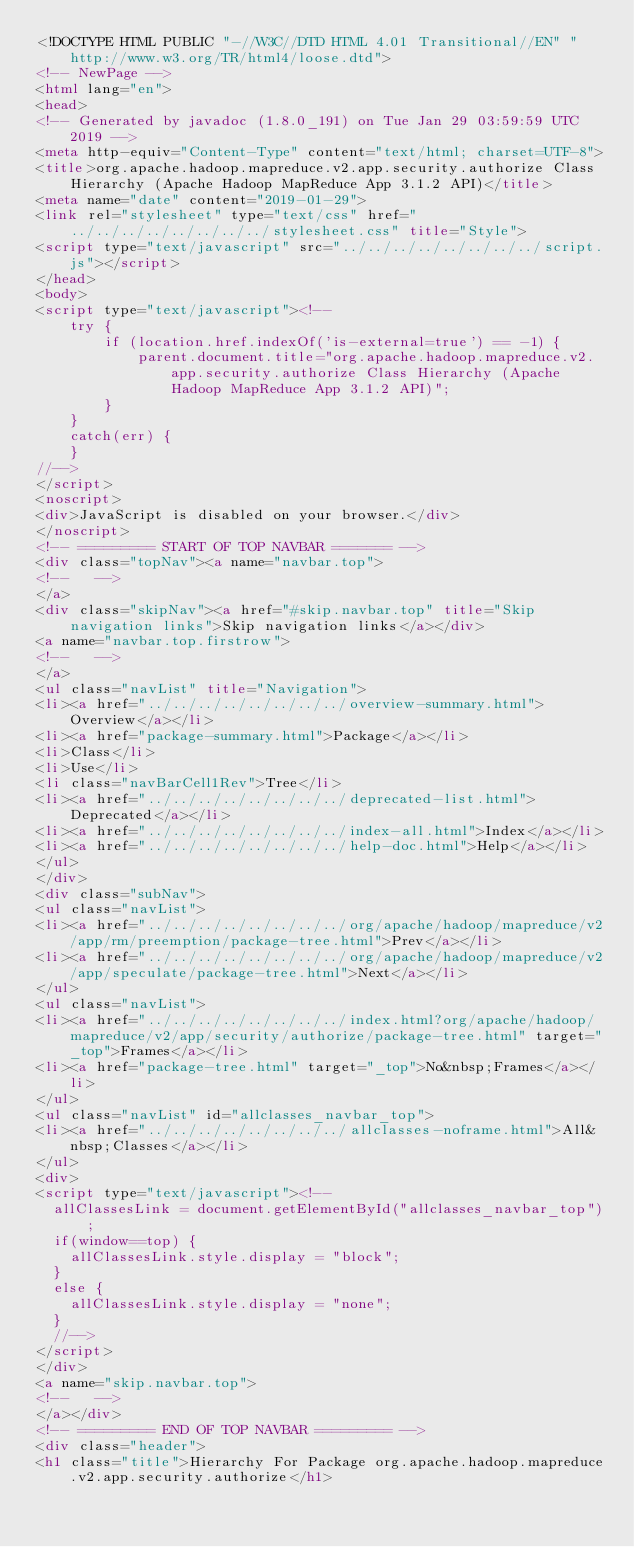Convert code to text. <code><loc_0><loc_0><loc_500><loc_500><_HTML_><!DOCTYPE HTML PUBLIC "-//W3C//DTD HTML 4.01 Transitional//EN" "http://www.w3.org/TR/html4/loose.dtd">
<!-- NewPage -->
<html lang="en">
<head>
<!-- Generated by javadoc (1.8.0_191) on Tue Jan 29 03:59:59 UTC 2019 -->
<meta http-equiv="Content-Type" content="text/html; charset=UTF-8">
<title>org.apache.hadoop.mapreduce.v2.app.security.authorize Class Hierarchy (Apache Hadoop MapReduce App 3.1.2 API)</title>
<meta name="date" content="2019-01-29">
<link rel="stylesheet" type="text/css" href="../../../../../../../../stylesheet.css" title="Style">
<script type="text/javascript" src="../../../../../../../../script.js"></script>
</head>
<body>
<script type="text/javascript"><!--
    try {
        if (location.href.indexOf('is-external=true') == -1) {
            parent.document.title="org.apache.hadoop.mapreduce.v2.app.security.authorize Class Hierarchy (Apache Hadoop MapReduce App 3.1.2 API)";
        }
    }
    catch(err) {
    }
//-->
</script>
<noscript>
<div>JavaScript is disabled on your browser.</div>
</noscript>
<!-- ========= START OF TOP NAVBAR ======= -->
<div class="topNav"><a name="navbar.top">
<!--   -->
</a>
<div class="skipNav"><a href="#skip.navbar.top" title="Skip navigation links">Skip navigation links</a></div>
<a name="navbar.top.firstrow">
<!--   -->
</a>
<ul class="navList" title="Navigation">
<li><a href="../../../../../../../../overview-summary.html">Overview</a></li>
<li><a href="package-summary.html">Package</a></li>
<li>Class</li>
<li>Use</li>
<li class="navBarCell1Rev">Tree</li>
<li><a href="../../../../../../../../deprecated-list.html">Deprecated</a></li>
<li><a href="../../../../../../../../index-all.html">Index</a></li>
<li><a href="../../../../../../../../help-doc.html">Help</a></li>
</ul>
</div>
<div class="subNav">
<ul class="navList">
<li><a href="../../../../../../../../org/apache/hadoop/mapreduce/v2/app/rm/preemption/package-tree.html">Prev</a></li>
<li><a href="../../../../../../../../org/apache/hadoop/mapreduce/v2/app/speculate/package-tree.html">Next</a></li>
</ul>
<ul class="navList">
<li><a href="../../../../../../../../index.html?org/apache/hadoop/mapreduce/v2/app/security/authorize/package-tree.html" target="_top">Frames</a></li>
<li><a href="package-tree.html" target="_top">No&nbsp;Frames</a></li>
</ul>
<ul class="navList" id="allclasses_navbar_top">
<li><a href="../../../../../../../../allclasses-noframe.html">All&nbsp;Classes</a></li>
</ul>
<div>
<script type="text/javascript"><!--
  allClassesLink = document.getElementById("allclasses_navbar_top");
  if(window==top) {
    allClassesLink.style.display = "block";
  }
  else {
    allClassesLink.style.display = "none";
  }
  //-->
</script>
</div>
<a name="skip.navbar.top">
<!--   -->
</a></div>
<!-- ========= END OF TOP NAVBAR ========= -->
<div class="header">
<h1 class="title">Hierarchy For Package org.apache.hadoop.mapreduce.v2.app.security.authorize</h1></code> 